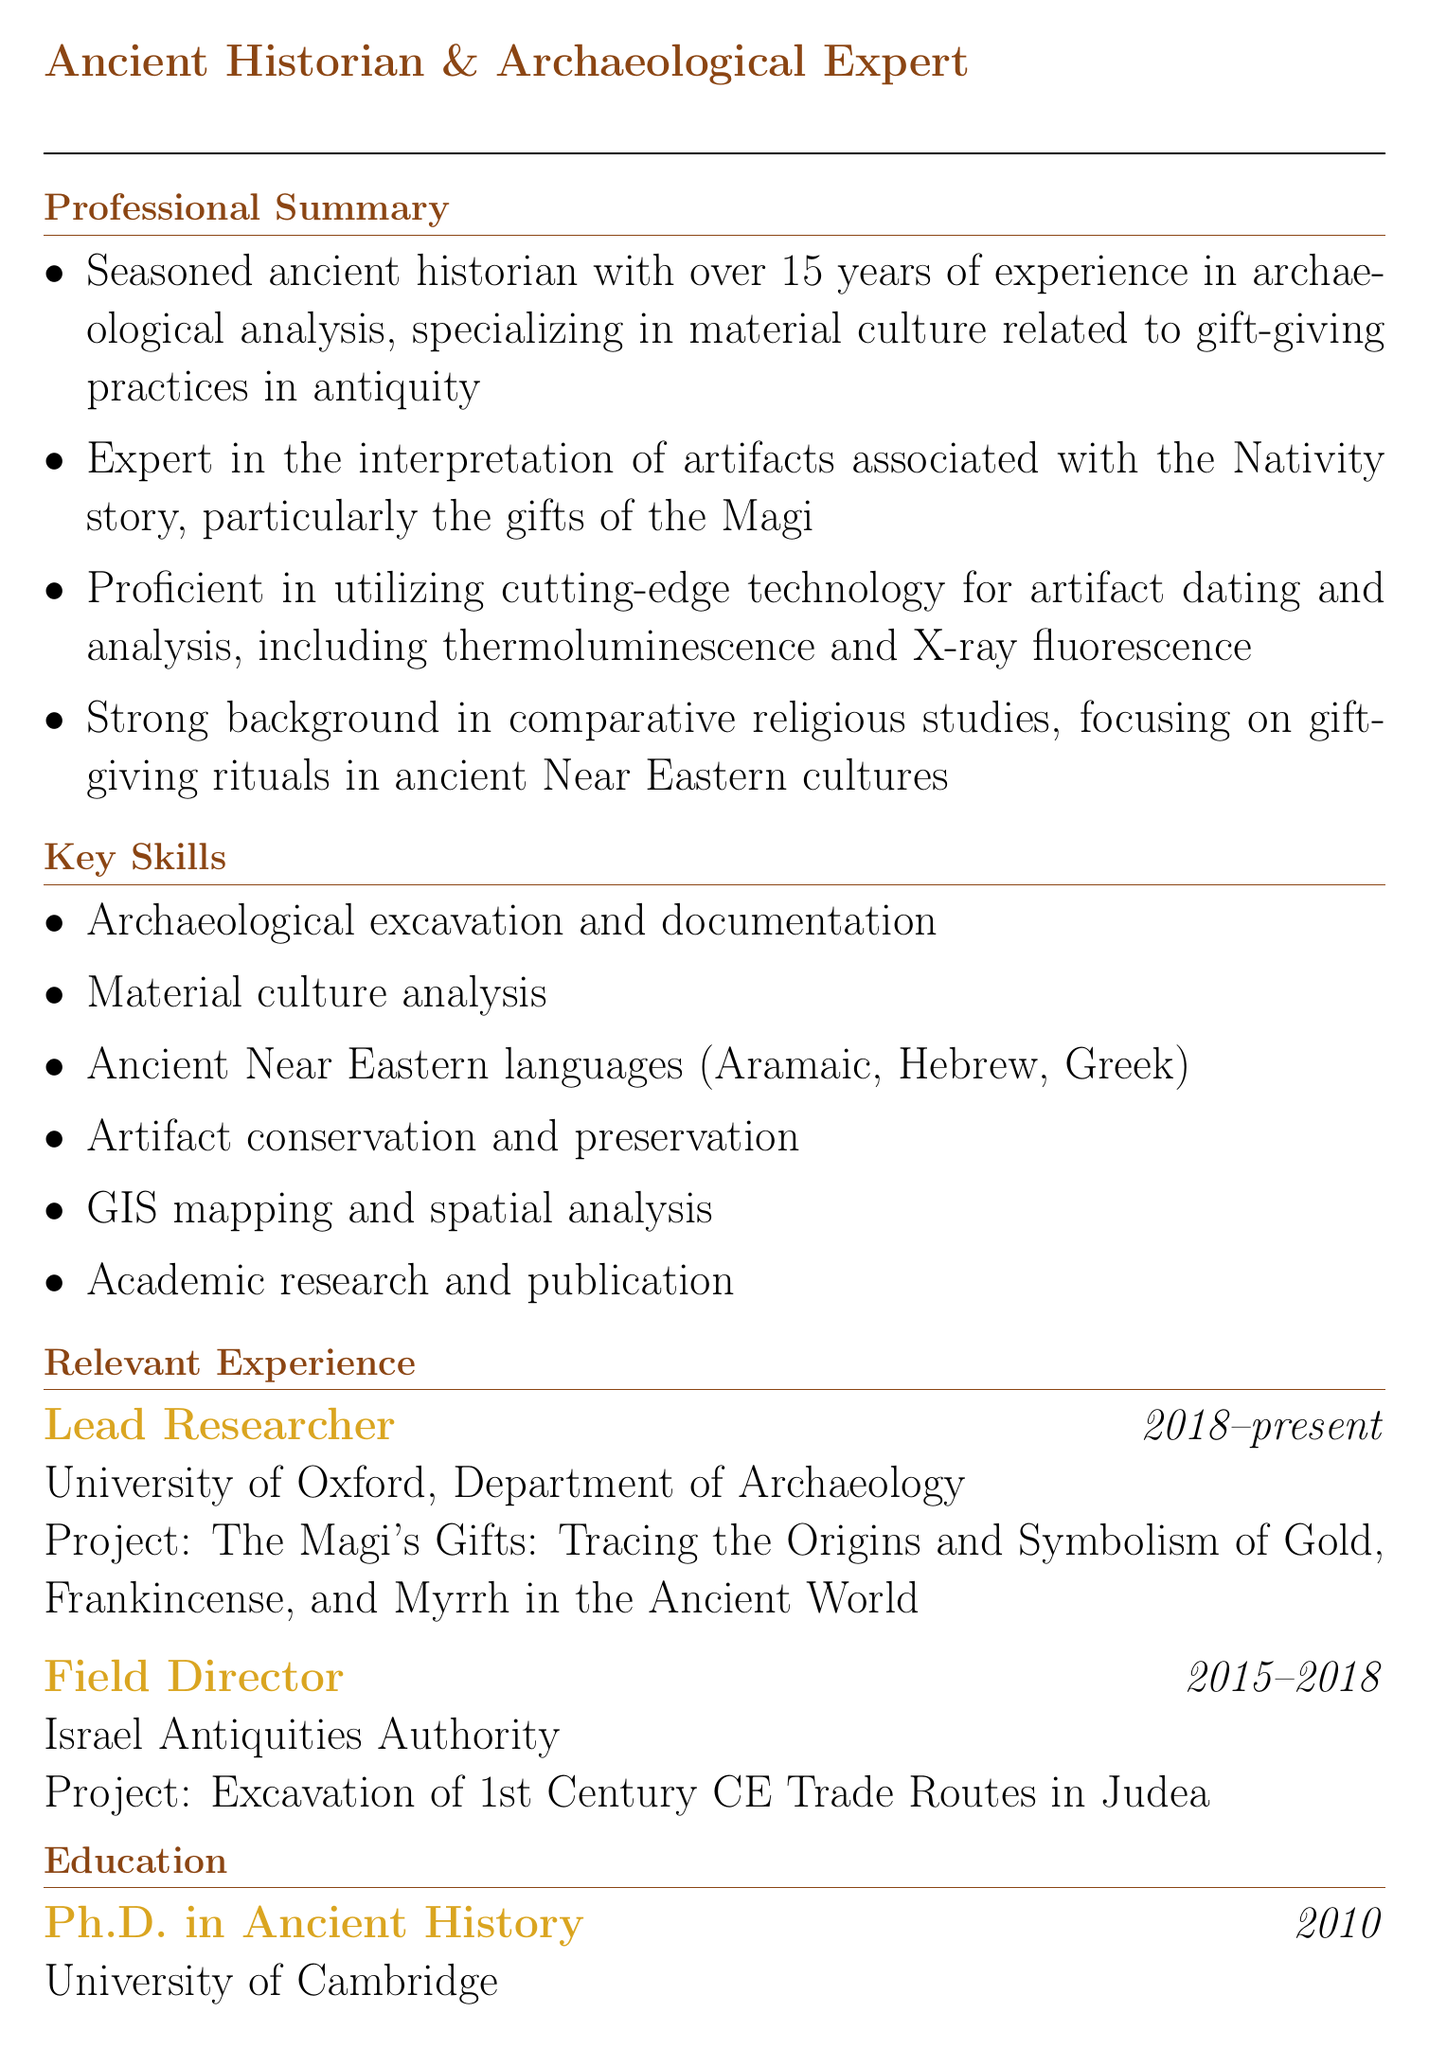What is the professional title of the individual? The professional title indicates the role and specialization of the individual in the document.
Answer: Ancient Historian & Archaeological Expert How many years of experience does the individual have? The years of experience are specifically mentioned in the professional summary section of the document.
Answer: Over 15 years What is the thesis topic of the individual's Ph.D.? The thesis topic gives insight into the individual's academic focus and expertise.
Answer: Gift-Giving Practices in the Hellenistic and Roman Near East: A Material Culture Approach What organization is the individual associated with as a Lead Researcher? The organization listed specifies where the individual is currently working in their role.
Answer: University of Oxford, Department of Archaeology In which year was the publication about the symbolism of the Magi's gifts released? The year of publication indicates the recency of the research and its relevance.
Answer: 2019 What technologies is the individual proficient in for artifact analysis? The mentioned technologies in the professional summary help to identify the individual's technical skills.
Answer: Thermoluminescence and X-ray fluorescence What was the duration of the individual's role as Field Director? The duration indicates the timeframe in which the individual held this position.
Answer: 2015-2018 Which cultures are the focus of the individual's comparative religious studies background? This question seeks to underline the specific cultural context of the individual's research expertise.
Answer: Ancient Near Eastern cultures 